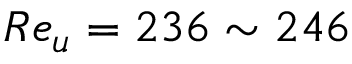Convert formula to latex. <formula><loc_0><loc_0><loc_500><loc_500>R e _ { u } = 2 3 6 \sim 2 4 6</formula> 